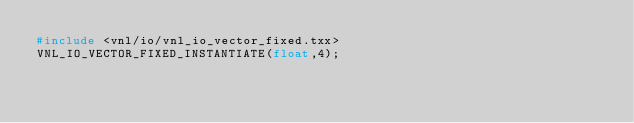Convert code to text. <code><loc_0><loc_0><loc_500><loc_500><_C++_>#include <vnl/io/vnl_io_vector_fixed.txx>
VNL_IO_VECTOR_FIXED_INSTANTIATE(float,4);
</code> 